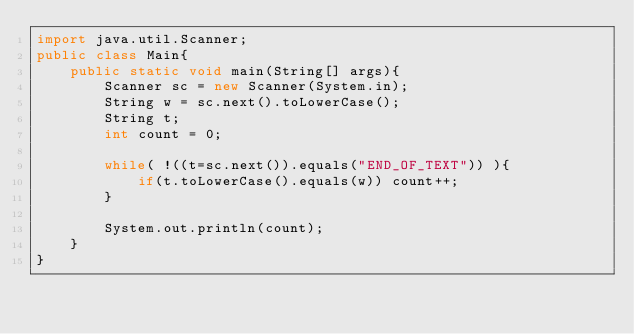<code> <loc_0><loc_0><loc_500><loc_500><_Java_>import java.util.Scanner;
public class Main{
    public static void main(String[] args){
        Scanner sc = new Scanner(System.in);
        String w = sc.next().toLowerCase();
        String t;
        int count = 0;

        while( !((t=sc.next()).equals("END_OF_TEXT")) ){
            if(t.toLowerCase().equals(w)) count++;
        }

        System.out.println(count);
    }
}
</code> 